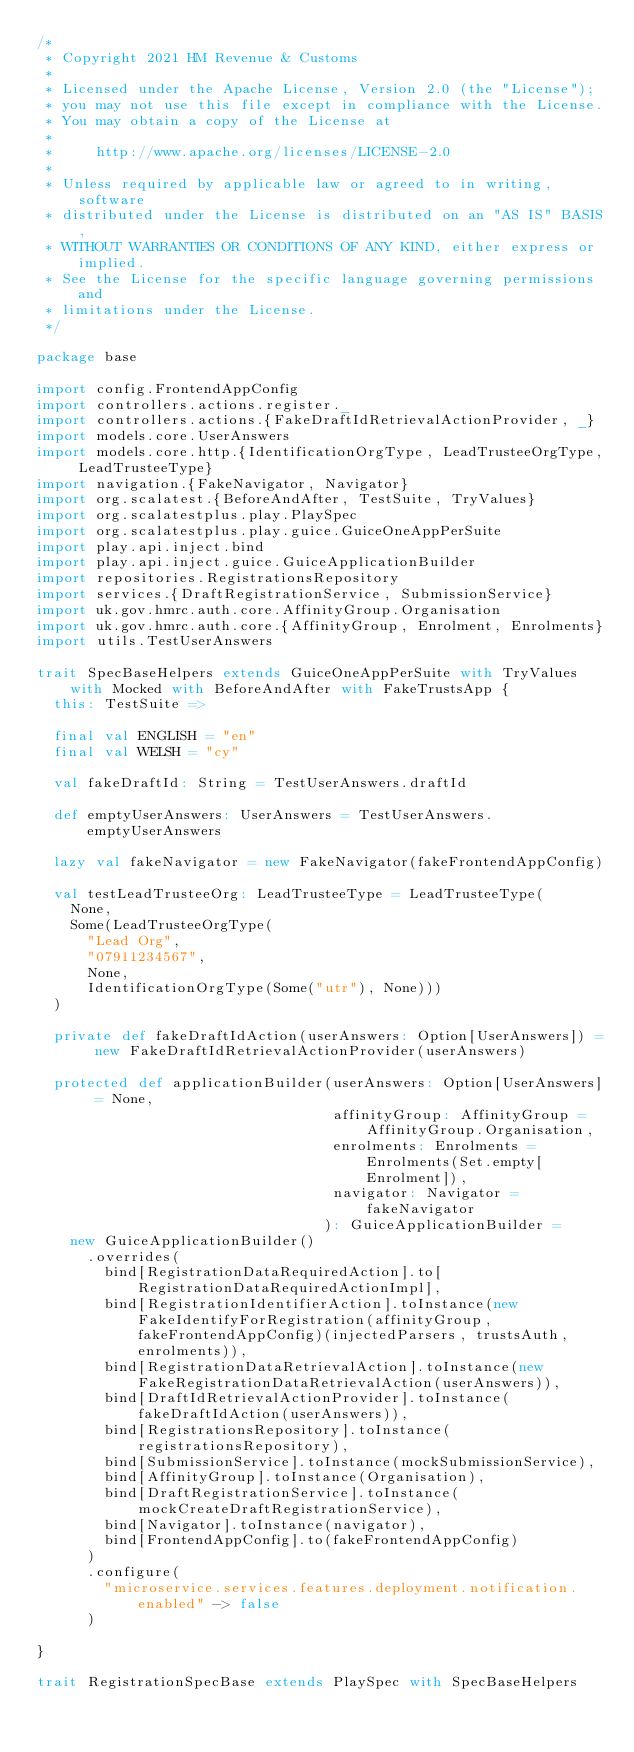<code> <loc_0><loc_0><loc_500><loc_500><_Scala_>/*
 * Copyright 2021 HM Revenue & Customs
 *
 * Licensed under the Apache License, Version 2.0 (the "License");
 * you may not use this file except in compliance with the License.
 * You may obtain a copy of the License at
 *
 *     http://www.apache.org/licenses/LICENSE-2.0
 *
 * Unless required by applicable law or agreed to in writing, software
 * distributed under the License is distributed on an "AS IS" BASIS,
 * WITHOUT WARRANTIES OR CONDITIONS OF ANY KIND, either express or implied.
 * See the License for the specific language governing permissions and
 * limitations under the License.
 */

package base

import config.FrontendAppConfig
import controllers.actions.register._
import controllers.actions.{FakeDraftIdRetrievalActionProvider, _}
import models.core.UserAnswers
import models.core.http.{IdentificationOrgType, LeadTrusteeOrgType, LeadTrusteeType}
import navigation.{FakeNavigator, Navigator}
import org.scalatest.{BeforeAndAfter, TestSuite, TryValues}
import org.scalatestplus.play.PlaySpec
import org.scalatestplus.play.guice.GuiceOneAppPerSuite
import play.api.inject.bind
import play.api.inject.guice.GuiceApplicationBuilder
import repositories.RegistrationsRepository
import services.{DraftRegistrationService, SubmissionService}
import uk.gov.hmrc.auth.core.AffinityGroup.Organisation
import uk.gov.hmrc.auth.core.{AffinityGroup, Enrolment, Enrolments}
import utils.TestUserAnswers

trait SpecBaseHelpers extends GuiceOneAppPerSuite with TryValues with Mocked with BeforeAndAfter with FakeTrustsApp {
  this: TestSuite =>

  final val ENGLISH = "en"
  final val WELSH = "cy"

  val fakeDraftId: String = TestUserAnswers.draftId

  def emptyUserAnswers: UserAnswers = TestUserAnswers.emptyUserAnswers

  lazy val fakeNavigator = new FakeNavigator(fakeFrontendAppConfig)

  val testLeadTrusteeOrg: LeadTrusteeType = LeadTrusteeType(
    None,
    Some(LeadTrusteeOrgType(
      "Lead Org",
      "07911234567",
      None,
      IdentificationOrgType(Some("utr"), None)))
  )

  private def fakeDraftIdAction(userAnswers: Option[UserAnswers]) = new FakeDraftIdRetrievalActionProvider(userAnswers)

  protected def applicationBuilder(userAnswers: Option[UserAnswers] = None,
                                   affinityGroup: AffinityGroup = AffinityGroup.Organisation,
                                   enrolments: Enrolments = Enrolments(Set.empty[Enrolment]),
                                   navigator: Navigator = fakeNavigator
                                  ): GuiceApplicationBuilder =
    new GuiceApplicationBuilder()
      .overrides(
        bind[RegistrationDataRequiredAction].to[RegistrationDataRequiredActionImpl],
        bind[RegistrationIdentifierAction].toInstance(new FakeIdentifyForRegistration(affinityGroup, fakeFrontendAppConfig)(injectedParsers, trustsAuth, enrolments)),
        bind[RegistrationDataRetrievalAction].toInstance(new FakeRegistrationDataRetrievalAction(userAnswers)),
        bind[DraftIdRetrievalActionProvider].toInstance(fakeDraftIdAction(userAnswers)),
        bind[RegistrationsRepository].toInstance(registrationsRepository),
        bind[SubmissionService].toInstance(mockSubmissionService),
        bind[AffinityGroup].toInstance(Organisation),
        bind[DraftRegistrationService].toInstance(mockCreateDraftRegistrationService),
        bind[Navigator].toInstance(navigator),
        bind[FrontendAppConfig].to(fakeFrontendAppConfig)
      )
      .configure(
        "microservice.services.features.deployment.notification.enabled" -> false
      )

}

trait RegistrationSpecBase extends PlaySpec with SpecBaseHelpers</code> 